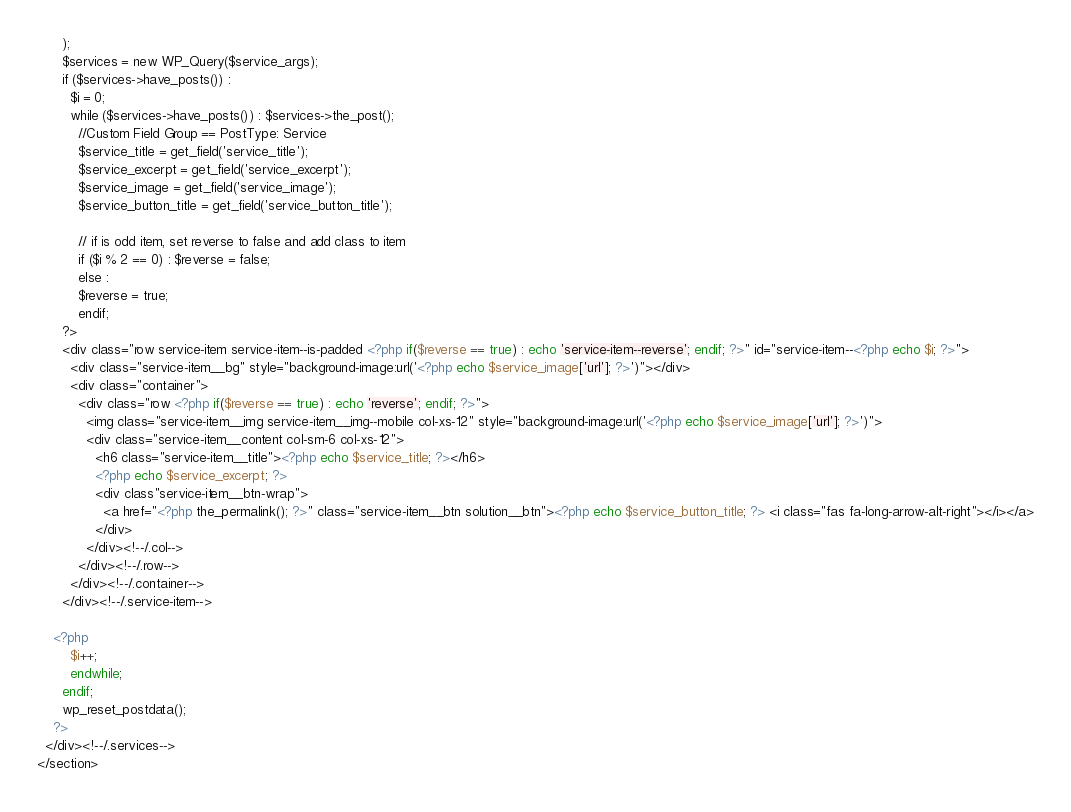Convert code to text. <code><loc_0><loc_0><loc_500><loc_500><_PHP_>      );
      $services = new WP_Query($service_args);
      if ($services->have_posts()) :
        $i = 0;
        while ($services->have_posts()) : $services->the_post();
          //Custom Field Group == PostType: Service
          $service_title = get_field('service_title'); 
          $service_excerpt = get_field('service_excerpt'); 
          $service_image = get_field('service_image'); 
          $service_button_title = get_field('service_button_title'); 

          // if is odd item, set reverse to false and add class to item
          if ($i % 2 == 0) : $reverse = false;
          else :
          $reverse = true;
          endif;
      ?>
      <div class="row service-item service-item--is-padded <?php if($reverse == true) : echo 'service-item--reverse'; endif; ?>" id="service-item--<?php echo $i; ?>">
        <div class="service-item__bg" style="background-image:url('<?php echo $service_image['url']; ?>')"></div>
        <div class="container">
          <div class="row <?php if($reverse == true) : echo 'reverse'; endif; ?>">
            <img class="service-item__img service-item__img--mobile col-xs-12" style="background-image:url('<?php echo $service_image['url']; ?>')">
            <div class="service-item__content col-sm-6 col-xs-12">
              <h6 class="service-item__title"><?php echo $service_title; ?></h6>
              <?php echo $service_excerpt; ?>
              <div class"service-item__btn-wrap">
                <a href="<?php the_permalink(); ?>" class="service-item__btn solution__btn"><?php echo $service_button_title; ?> <i class="fas fa-long-arrow-alt-right"></i></a>
              </div>
            </div><!--/.col-->
          </div><!--/.row-->
        </div><!--/.container-->
      </div><!--/.service-item-->
        
    <?php
        $i++;
        endwhile;
      endif;
      wp_reset_postdata();
    ?>
  </div><!--/.services-->
</section></code> 